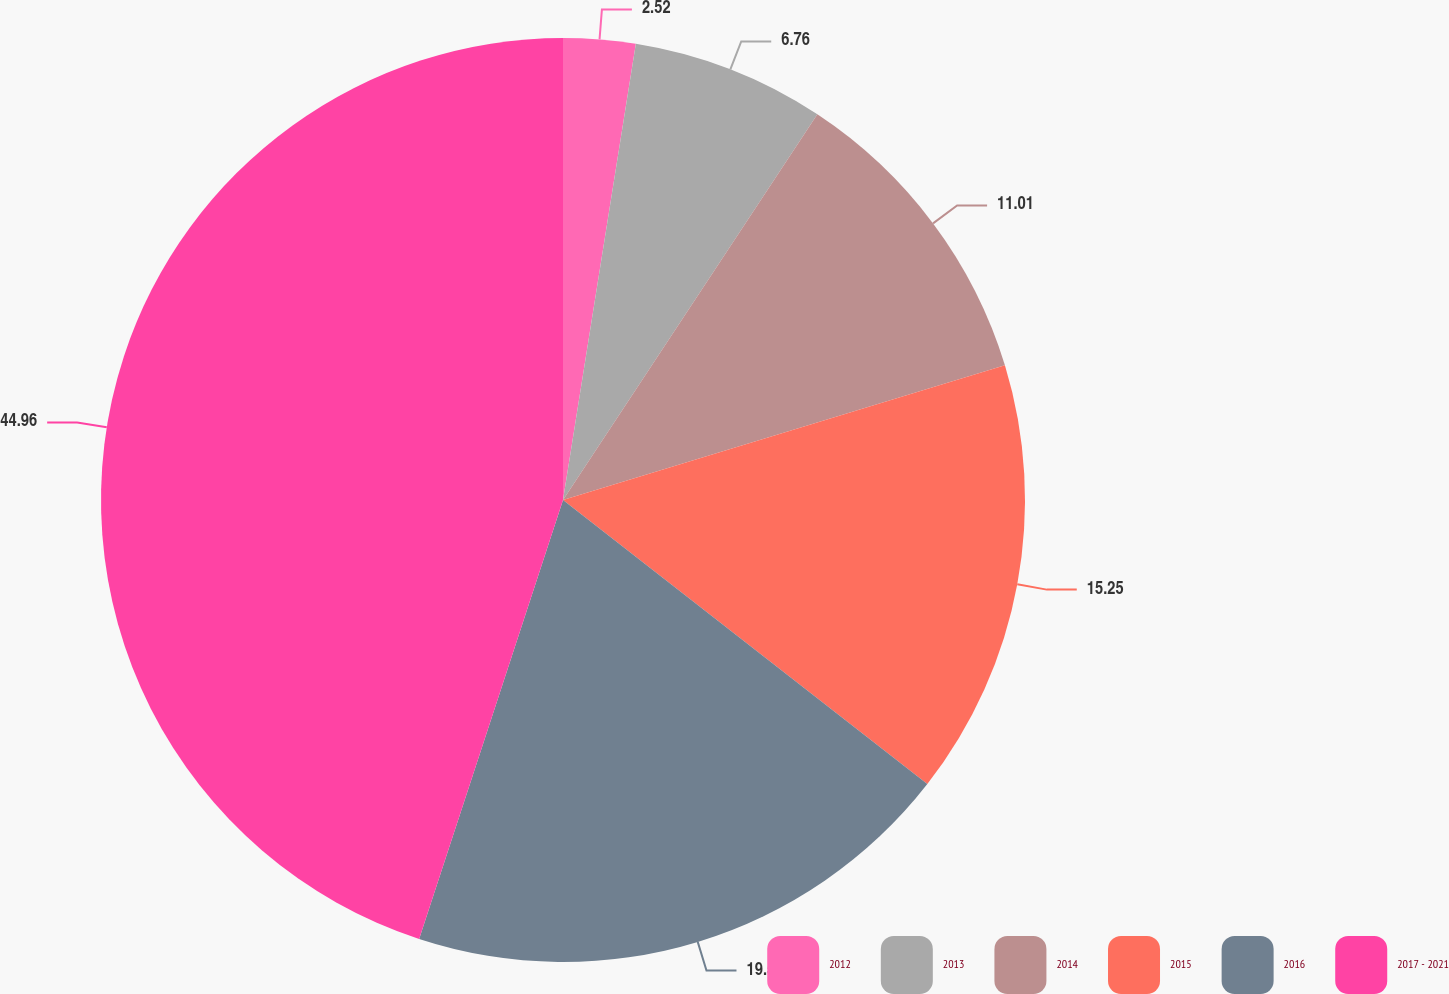Convert chart to OTSL. <chart><loc_0><loc_0><loc_500><loc_500><pie_chart><fcel>2012<fcel>2013<fcel>2014<fcel>2015<fcel>2016<fcel>2017 - 2021<nl><fcel>2.52%<fcel>6.76%<fcel>11.01%<fcel>15.25%<fcel>19.5%<fcel>44.96%<nl></chart> 